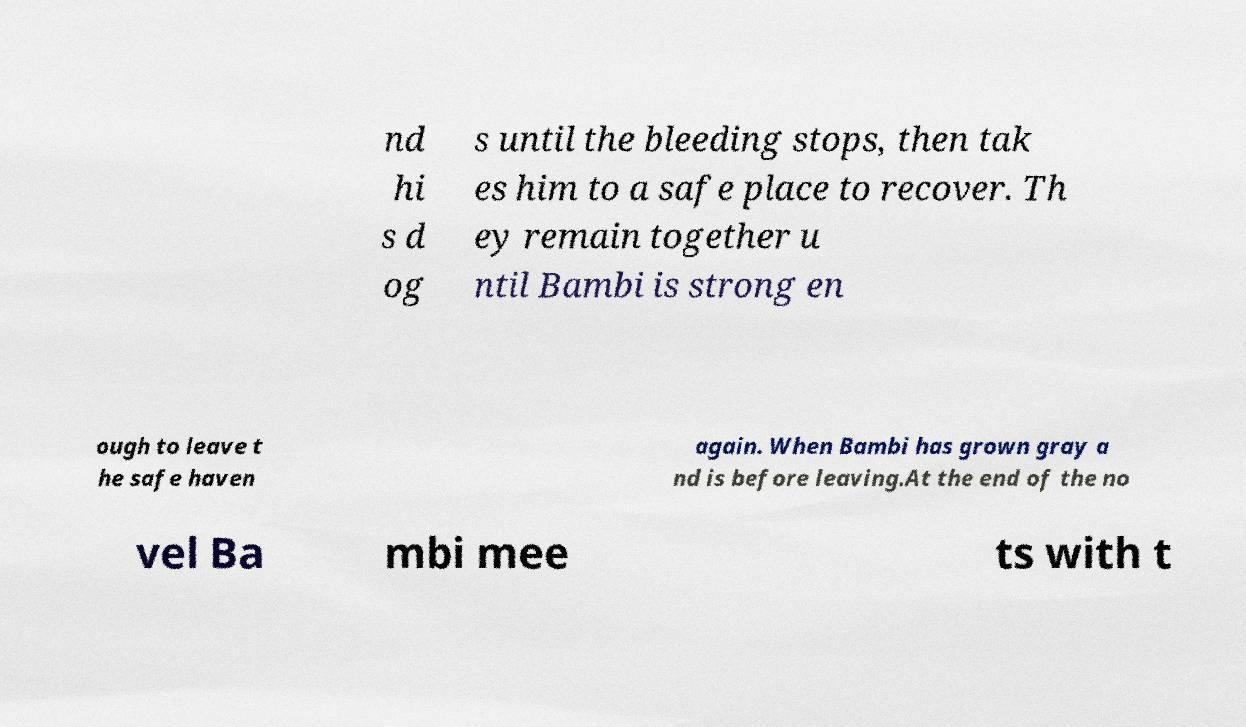I need the written content from this picture converted into text. Can you do that? nd hi s d og s until the bleeding stops, then tak es him to a safe place to recover. Th ey remain together u ntil Bambi is strong en ough to leave t he safe haven again. When Bambi has grown gray a nd is before leaving.At the end of the no vel Ba mbi mee ts with t 